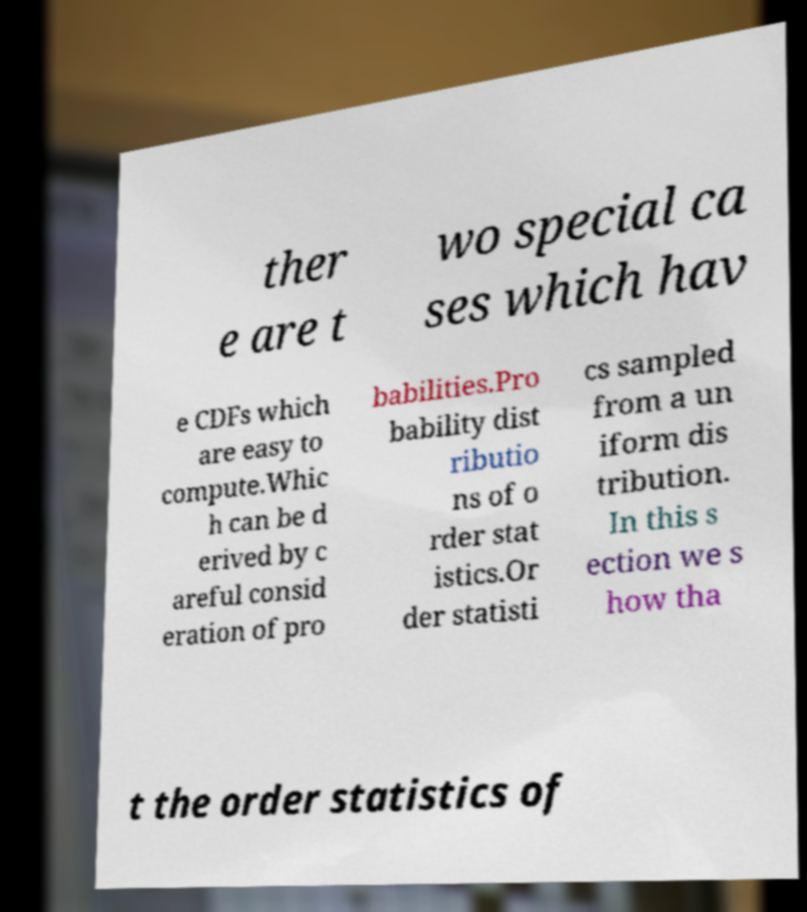Can you read and provide the text displayed in the image?This photo seems to have some interesting text. Can you extract and type it out for me? ther e are t wo special ca ses which hav e CDFs which are easy to compute.Whic h can be d erived by c areful consid eration of pro babilities.Pro bability dist ributio ns of o rder stat istics.Or der statisti cs sampled from a un iform dis tribution. In this s ection we s how tha t the order statistics of 